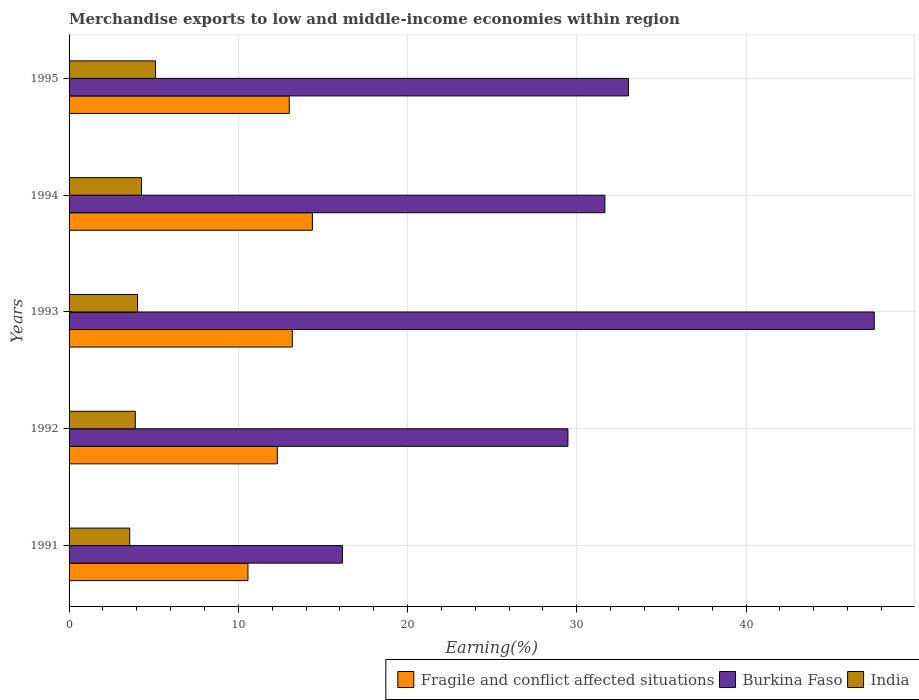Are the number of bars per tick equal to the number of legend labels?
Your response must be concise. Yes. In how many cases, is the number of bars for a given year not equal to the number of legend labels?
Give a very brief answer. 0. What is the percentage of amount earned from merchandise exports in Fragile and conflict affected situations in 1994?
Your answer should be compact. 14.38. Across all years, what is the maximum percentage of amount earned from merchandise exports in India?
Your answer should be compact. 5.11. Across all years, what is the minimum percentage of amount earned from merchandise exports in Fragile and conflict affected situations?
Provide a succinct answer. 10.57. In which year was the percentage of amount earned from merchandise exports in Burkina Faso maximum?
Offer a very short reply. 1993. What is the total percentage of amount earned from merchandise exports in Burkina Faso in the graph?
Provide a succinct answer. 157.92. What is the difference between the percentage of amount earned from merchandise exports in Burkina Faso in 1991 and that in 1993?
Ensure brevity in your answer.  -31.43. What is the difference between the percentage of amount earned from merchandise exports in Burkina Faso in 1991 and the percentage of amount earned from merchandise exports in India in 1995?
Give a very brief answer. 11.04. What is the average percentage of amount earned from merchandise exports in Burkina Faso per year?
Provide a succinct answer. 31.58. In the year 1992, what is the difference between the percentage of amount earned from merchandise exports in Fragile and conflict affected situations and percentage of amount earned from merchandise exports in Burkina Faso?
Ensure brevity in your answer.  -17.17. In how many years, is the percentage of amount earned from merchandise exports in India greater than 40 %?
Provide a short and direct response. 0. What is the ratio of the percentage of amount earned from merchandise exports in Fragile and conflict affected situations in 1992 to that in 1993?
Keep it short and to the point. 0.93. Is the percentage of amount earned from merchandise exports in India in 1991 less than that in 1992?
Your answer should be very brief. Yes. Is the difference between the percentage of amount earned from merchandise exports in Fragile and conflict affected situations in 1993 and 1995 greater than the difference between the percentage of amount earned from merchandise exports in Burkina Faso in 1993 and 1995?
Ensure brevity in your answer.  No. What is the difference between the highest and the second highest percentage of amount earned from merchandise exports in India?
Ensure brevity in your answer.  0.83. What is the difference between the highest and the lowest percentage of amount earned from merchandise exports in Burkina Faso?
Give a very brief answer. 31.43. What does the 2nd bar from the top in 1995 represents?
Your answer should be very brief. Burkina Faso. What does the 2nd bar from the bottom in 1995 represents?
Offer a terse response. Burkina Faso. Is it the case that in every year, the sum of the percentage of amount earned from merchandise exports in India and percentage of amount earned from merchandise exports in Fragile and conflict affected situations is greater than the percentage of amount earned from merchandise exports in Burkina Faso?
Your answer should be compact. No. Are all the bars in the graph horizontal?
Give a very brief answer. Yes. How many years are there in the graph?
Make the answer very short. 5. Are the values on the major ticks of X-axis written in scientific E-notation?
Ensure brevity in your answer.  No. Does the graph contain any zero values?
Offer a very short reply. No. Does the graph contain grids?
Your answer should be very brief. Yes. What is the title of the graph?
Make the answer very short. Merchandise exports to low and middle-income economies within region. Does "Macao" appear as one of the legend labels in the graph?
Give a very brief answer. No. What is the label or title of the X-axis?
Offer a terse response. Earning(%). What is the Earning(%) in Fragile and conflict affected situations in 1991?
Offer a terse response. 10.57. What is the Earning(%) in Burkina Faso in 1991?
Your answer should be compact. 16.15. What is the Earning(%) in India in 1991?
Offer a very short reply. 3.58. What is the Earning(%) of Fragile and conflict affected situations in 1992?
Offer a terse response. 12.31. What is the Earning(%) in Burkina Faso in 1992?
Provide a short and direct response. 29.48. What is the Earning(%) of India in 1992?
Your response must be concise. 3.91. What is the Earning(%) of Fragile and conflict affected situations in 1993?
Make the answer very short. 13.19. What is the Earning(%) of Burkina Faso in 1993?
Your response must be concise. 47.58. What is the Earning(%) in India in 1993?
Provide a succinct answer. 4.05. What is the Earning(%) in Fragile and conflict affected situations in 1994?
Your answer should be compact. 14.38. What is the Earning(%) in Burkina Faso in 1994?
Offer a terse response. 31.66. What is the Earning(%) of India in 1994?
Offer a very short reply. 4.28. What is the Earning(%) of Fragile and conflict affected situations in 1995?
Your response must be concise. 13.01. What is the Earning(%) in Burkina Faso in 1995?
Offer a very short reply. 33.05. What is the Earning(%) of India in 1995?
Keep it short and to the point. 5.11. Across all years, what is the maximum Earning(%) in Fragile and conflict affected situations?
Your answer should be very brief. 14.38. Across all years, what is the maximum Earning(%) of Burkina Faso?
Offer a terse response. 47.58. Across all years, what is the maximum Earning(%) of India?
Keep it short and to the point. 5.11. Across all years, what is the minimum Earning(%) of Fragile and conflict affected situations?
Keep it short and to the point. 10.57. Across all years, what is the minimum Earning(%) of Burkina Faso?
Your answer should be compact. 16.15. Across all years, what is the minimum Earning(%) of India?
Your answer should be compact. 3.58. What is the total Earning(%) in Fragile and conflict affected situations in the graph?
Provide a succinct answer. 63.45. What is the total Earning(%) in Burkina Faso in the graph?
Offer a terse response. 157.92. What is the total Earning(%) of India in the graph?
Make the answer very short. 20.93. What is the difference between the Earning(%) of Fragile and conflict affected situations in 1991 and that in 1992?
Your answer should be compact. -1.74. What is the difference between the Earning(%) of Burkina Faso in 1991 and that in 1992?
Give a very brief answer. -13.33. What is the difference between the Earning(%) of India in 1991 and that in 1992?
Your answer should be very brief. -0.33. What is the difference between the Earning(%) in Fragile and conflict affected situations in 1991 and that in 1993?
Provide a short and direct response. -2.62. What is the difference between the Earning(%) of Burkina Faso in 1991 and that in 1993?
Your answer should be very brief. -31.43. What is the difference between the Earning(%) of India in 1991 and that in 1993?
Your response must be concise. -0.46. What is the difference between the Earning(%) of Fragile and conflict affected situations in 1991 and that in 1994?
Give a very brief answer. -3.81. What is the difference between the Earning(%) of Burkina Faso in 1991 and that in 1994?
Offer a terse response. -15.51. What is the difference between the Earning(%) in India in 1991 and that in 1994?
Offer a terse response. -0.69. What is the difference between the Earning(%) of Fragile and conflict affected situations in 1991 and that in 1995?
Give a very brief answer. -2.44. What is the difference between the Earning(%) in Burkina Faso in 1991 and that in 1995?
Ensure brevity in your answer.  -16.9. What is the difference between the Earning(%) in India in 1991 and that in 1995?
Give a very brief answer. -1.52. What is the difference between the Earning(%) of Fragile and conflict affected situations in 1992 and that in 1993?
Provide a short and direct response. -0.88. What is the difference between the Earning(%) in Burkina Faso in 1992 and that in 1993?
Provide a short and direct response. -18.1. What is the difference between the Earning(%) of India in 1992 and that in 1993?
Your response must be concise. -0.13. What is the difference between the Earning(%) in Fragile and conflict affected situations in 1992 and that in 1994?
Give a very brief answer. -2.07. What is the difference between the Earning(%) in Burkina Faso in 1992 and that in 1994?
Offer a terse response. -2.18. What is the difference between the Earning(%) of India in 1992 and that in 1994?
Provide a short and direct response. -0.36. What is the difference between the Earning(%) of Fragile and conflict affected situations in 1992 and that in 1995?
Give a very brief answer. -0.71. What is the difference between the Earning(%) of Burkina Faso in 1992 and that in 1995?
Your answer should be compact. -3.58. What is the difference between the Earning(%) of India in 1992 and that in 1995?
Provide a succinct answer. -1.19. What is the difference between the Earning(%) of Fragile and conflict affected situations in 1993 and that in 1994?
Your answer should be very brief. -1.19. What is the difference between the Earning(%) in Burkina Faso in 1993 and that in 1994?
Offer a very short reply. 15.92. What is the difference between the Earning(%) in India in 1993 and that in 1994?
Your answer should be very brief. -0.23. What is the difference between the Earning(%) of Fragile and conflict affected situations in 1993 and that in 1995?
Your answer should be compact. 0.18. What is the difference between the Earning(%) of Burkina Faso in 1993 and that in 1995?
Ensure brevity in your answer.  14.52. What is the difference between the Earning(%) of India in 1993 and that in 1995?
Offer a terse response. -1.06. What is the difference between the Earning(%) of Fragile and conflict affected situations in 1994 and that in 1995?
Give a very brief answer. 1.37. What is the difference between the Earning(%) in Burkina Faso in 1994 and that in 1995?
Your answer should be compact. -1.4. What is the difference between the Earning(%) in India in 1994 and that in 1995?
Provide a succinct answer. -0.83. What is the difference between the Earning(%) in Fragile and conflict affected situations in 1991 and the Earning(%) in Burkina Faso in 1992?
Provide a short and direct response. -18.91. What is the difference between the Earning(%) of Fragile and conflict affected situations in 1991 and the Earning(%) of India in 1992?
Provide a short and direct response. 6.66. What is the difference between the Earning(%) of Burkina Faso in 1991 and the Earning(%) of India in 1992?
Keep it short and to the point. 12.24. What is the difference between the Earning(%) of Fragile and conflict affected situations in 1991 and the Earning(%) of Burkina Faso in 1993?
Ensure brevity in your answer.  -37.01. What is the difference between the Earning(%) in Fragile and conflict affected situations in 1991 and the Earning(%) in India in 1993?
Your answer should be very brief. 6.52. What is the difference between the Earning(%) in Burkina Faso in 1991 and the Earning(%) in India in 1993?
Give a very brief answer. 12.1. What is the difference between the Earning(%) of Fragile and conflict affected situations in 1991 and the Earning(%) of Burkina Faso in 1994?
Keep it short and to the point. -21.09. What is the difference between the Earning(%) of Fragile and conflict affected situations in 1991 and the Earning(%) of India in 1994?
Your answer should be very brief. 6.29. What is the difference between the Earning(%) of Burkina Faso in 1991 and the Earning(%) of India in 1994?
Give a very brief answer. 11.87. What is the difference between the Earning(%) of Fragile and conflict affected situations in 1991 and the Earning(%) of Burkina Faso in 1995?
Ensure brevity in your answer.  -22.48. What is the difference between the Earning(%) in Fragile and conflict affected situations in 1991 and the Earning(%) in India in 1995?
Provide a succinct answer. 5.46. What is the difference between the Earning(%) in Burkina Faso in 1991 and the Earning(%) in India in 1995?
Offer a very short reply. 11.04. What is the difference between the Earning(%) of Fragile and conflict affected situations in 1992 and the Earning(%) of Burkina Faso in 1993?
Ensure brevity in your answer.  -35.27. What is the difference between the Earning(%) in Fragile and conflict affected situations in 1992 and the Earning(%) in India in 1993?
Offer a terse response. 8.26. What is the difference between the Earning(%) in Burkina Faso in 1992 and the Earning(%) in India in 1993?
Make the answer very short. 25.43. What is the difference between the Earning(%) of Fragile and conflict affected situations in 1992 and the Earning(%) of Burkina Faso in 1994?
Make the answer very short. -19.35. What is the difference between the Earning(%) in Fragile and conflict affected situations in 1992 and the Earning(%) in India in 1994?
Your response must be concise. 8.03. What is the difference between the Earning(%) of Burkina Faso in 1992 and the Earning(%) of India in 1994?
Provide a succinct answer. 25.2. What is the difference between the Earning(%) in Fragile and conflict affected situations in 1992 and the Earning(%) in Burkina Faso in 1995?
Offer a very short reply. -20.75. What is the difference between the Earning(%) of Fragile and conflict affected situations in 1992 and the Earning(%) of India in 1995?
Offer a terse response. 7.2. What is the difference between the Earning(%) in Burkina Faso in 1992 and the Earning(%) in India in 1995?
Your answer should be compact. 24.37. What is the difference between the Earning(%) of Fragile and conflict affected situations in 1993 and the Earning(%) of Burkina Faso in 1994?
Give a very brief answer. -18.47. What is the difference between the Earning(%) in Fragile and conflict affected situations in 1993 and the Earning(%) in India in 1994?
Your answer should be compact. 8.91. What is the difference between the Earning(%) of Burkina Faso in 1993 and the Earning(%) of India in 1994?
Make the answer very short. 43.3. What is the difference between the Earning(%) in Fragile and conflict affected situations in 1993 and the Earning(%) in Burkina Faso in 1995?
Make the answer very short. -19.86. What is the difference between the Earning(%) of Fragile and conflict affected situations in 1993 and the Earning(%) of India in 1995?
Provide a succinct answer. 8.08. What is the difference between the Earning(%) of Burkina Faso in 1993 and the Earning(%) of India in 1995?
Give a very brief answer. 42.47. What is the difference between the Earning(%) of Fragile and conflict affected situations in 1994 and the Earning(%) of Burkina Faso in 1995?
Ensure brevity in your answer.  -18.68. What is the difference between the Earning(%) in Fragile and conflict affected situations in 1994 and the Earning(%) in India in 1995?
Provide a succinct answer. 9.27. What is the difference between the Earning(%) in Burkina Faso in 1994 and the Earning(%) in India in 1995?
Ensure brevity in your answer.  26.55. What is the average Earning(%) in Fragile and conflict affected situations per year?
Ensure brevity in your answer.  12.69. What is the average Earning(%) of Burkina Faso per year?
Your answer should be very brief. 31.58. What is the average Earning(%) in India per year?
Offer a terse response. 4.19. In the year 1991, what is the difference between the Earning(%) in Fragile and conflict affected situations and Earning(%) in Burkina Faso?
Offer a terse response. -5.58. In the year 1991, what is the difference between the Earning(%) of Fragile and conflict affected situations and Earning(%) of India?
Make the answer very short. 6.98. In the year 1991, what is the difference between the Earning(%) in Burkina Faso and Earning(%) in India?
Provide a short and direct response. 12.57. In the year 1992, what is the difference between the Earning(%) in Fragile and conflict affected situations and Earning(%) in Burkina Faso?
Your answer should be very brief. -17.17. In the year 1992, what is the difference between the Earning(%) of Fragile and conflict affected situations and Earning(%) of India?
Keep it short and to the point. 8.39. In the year 1992, what is the difference between the Earning(%) in Burkina Faso and Earning(%) in India?
Offer a very short reply. 25.56. In the year 1993, what is the difference between the Earning(%) of Fragile and conflict affected situations and Earning(%) of Burkina Faso?
Your answer should be compact. -34.39. In the year 1993, what is the difference between the Earning(%) of Fragile and conflict affected situations and Earning(%) of India?
Your answer should be very brief. 9.14. In the year 1993, what is the difference between the Earning(%) in Burkina Faso and Earning(%) in India?
Give a very brief answer. 43.53. In the year 1994, what is the difference between the Earning(%) of Fragile and conflict affected situations and Earning(%) of Burkina Faso?
Ensure brevity in your answer.  -17.28. In the year 1994, what is the difference between the Earning(%) of Fragile and conflict affected situations and Earning(%) of India?
Keep it short and to the point. 10.1. In the year 1994, what is the difference between the Earning(%) of Burkina Faso and Earning(%) of India?
Your response must be concise. 27.38. In the year 1995, what is the difference between the Earning(%) of Fragile and conflict affected situations and Earning(%) of Burkina Faso?
Your answer should be compact. -20.04. In the year 1995, what is the difference between the Earning(%) of Fragile and conflict affected situations and Earning(%) of India?
Provide a succinct answer. 7.9. In the year 1995, what is the difference between the Earning(%) in Burkina Faso and Earning(%) in India?
Offer a very short reply. 27.95. What is the ratio of the Earning(%) in Fragile and conflict affected situations in 1991 to that in 1992?
Give a very brief answer. 0.86. What is the ratio of the Earning(%) in Burkina Faso in 1991 to that in 1992?
Offer a very short reply. 0.55. What is the ratio of the Earning(%) of India in 1991 to that in 1992?
Keep it short and to the point. 0.92. What is the ratio of the Earning(%) of Fragile and conflict affected situations in 1991 to that in 1993?
Keep it short and to the point. 0.8. What is the ratio of the Earning(%) in Burkina Faso in 1991 to that in 1993?
Offer a terse response. 0.34. What is the ratio of the Earning(%) of India in 1991 to that in 1993?
Your answer should be very brief. 0.89. What is the ratio of the Earning(%) in Fragile and conflict affected situations in 1991 to that in 1994?
Make the answer very short. 0.74. What is the ratio of the Earning(%) in Burkina Faso in 1991 to that in 1994?
Offer a terse response. 0.51. What is the ratio of the Earning(%) in India in 1991 to that in 1994?
Keep it short and to the point. 0.84. What is the ratio of the Earning(%) of Fragile and conflict affected situations in 1991 to that in 1995?
Ensure brevity in your answer.  0.81. What is the ratio of the Earning(%) in Burkina Faso in 1991 to that in 1995?
Your response must be concise. 0.49. What is the ratio of the Earning(%) of India in 1991 to that in 1995?
Your answer should be compact. 0.7. What is the ratio of the Earning(%) of Fragile and conflict affected situations in 1992 to that in 1993?
Provide a succinct answer. 0.93. What is the ratio of the Earning(%) in Burkina Faso in 1992 to that in 1993?
Your response must be concise. 0.62. What is the ratio of the Earning(%) in India in 1992 to that in 1993?
Your response must be concise. 0.97. What is the ratio of the Earning(%) of Fragile and conflict affected situations in 1992 to that in 1994?
Keep it short and to the point. 0.86. What is the ratio of the Earning(%) of India in 1992 to that in 1994?
Your response must be concise. 0.91. What is the ratio of the Earning(%) of Fragile and conflict affected situations in 1992 to that in 1995?
Your answer should be compact. 0.95. What is the ratio of the Earning(%) of Burkina Faso in 1992 to that in 1995?
Make the answer very short. 0.89. What is the ratio of the Earning(%) of India in 1992 to that in 1995?
Keep it short and to the point. 0.77. What is the ratio of the Earning(%) of Fragile and conflict affected situations in 1993 to that in 1994?
Make the answer very short. 0.92. What is the ratio of the Earning(%) of Burkina Faso in 1993 to that in 1994?
Make the answer very short. 1.5. What is the ratio of the Earning(%) in India in 1993 to that in 1994?
Make the answer very short. 0.95. What is the ratio of the Earning(%) in Fragile and conflict affected situations in 1993 to that in 1995?
Keep it short and to the point. 1.01. What is the ratio of the Earning(%) in Burkina Faso in 1993 to that in 1995?
Keep it short and to the point. 1.44. What is the ratio of the Earning(%) in India in 1993 to that in 1995?
Ensure brevity in your answer.  0.79. What is the ratio of the Earning(%) in Fragile and conflict affected situations in 1994 to that in 1995?
Offer a very short reply. 1.11. What is the ratio of the Earning(%) in Burkina Faso in 1994 to that in 1995?
Offer a very short reply. 0.96. What is the ratio of the Earning(%) in India in 1994 to that in 1995?
Your response must be concise. 0.84. What is the difference between the highest and the second highest Earning(%) in Fragile and conflict affected situations?
Offer a terse response. 1.19. What is the difference between the highest and the second highest Earning(%) of Burkina Faso?
Offer a terse response. 14.52. What is the difference between the highest and the second highest Earning(%) in India?
Your answer should be very brief. 0.83. What is the difference between the highest and the lowest Earning(%) in Fragile and conflict affected situations?
Your answer should be very brief. 3.81. What is the difference between the highest and the lowest Earning(%) of Burkina Faso?
Offer a very short reply. 31.43. What is the difference between the highest and the lowest Earning(%) of India?
Your answer should be compact. 1.52. 